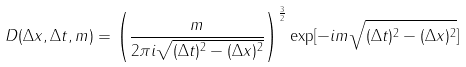Convert formula to latex. <formula><loc_0><loc_0><loc_500><loc_500>D ( \Delta x , \Delta t , m ) = \left ( \frac { m } { 2 \pi i \sqrt { ( \Delta t ) ^ { 2 } - ( \Delta x ) ^ { 2 } } } \right ) ^ { \frac { 3 } { 2 } } \exp [ - i m \sqrt { ( \Delta t ) ^ { 2 } - ( \Delta x ) ^ { 2 } } ]</formula> 